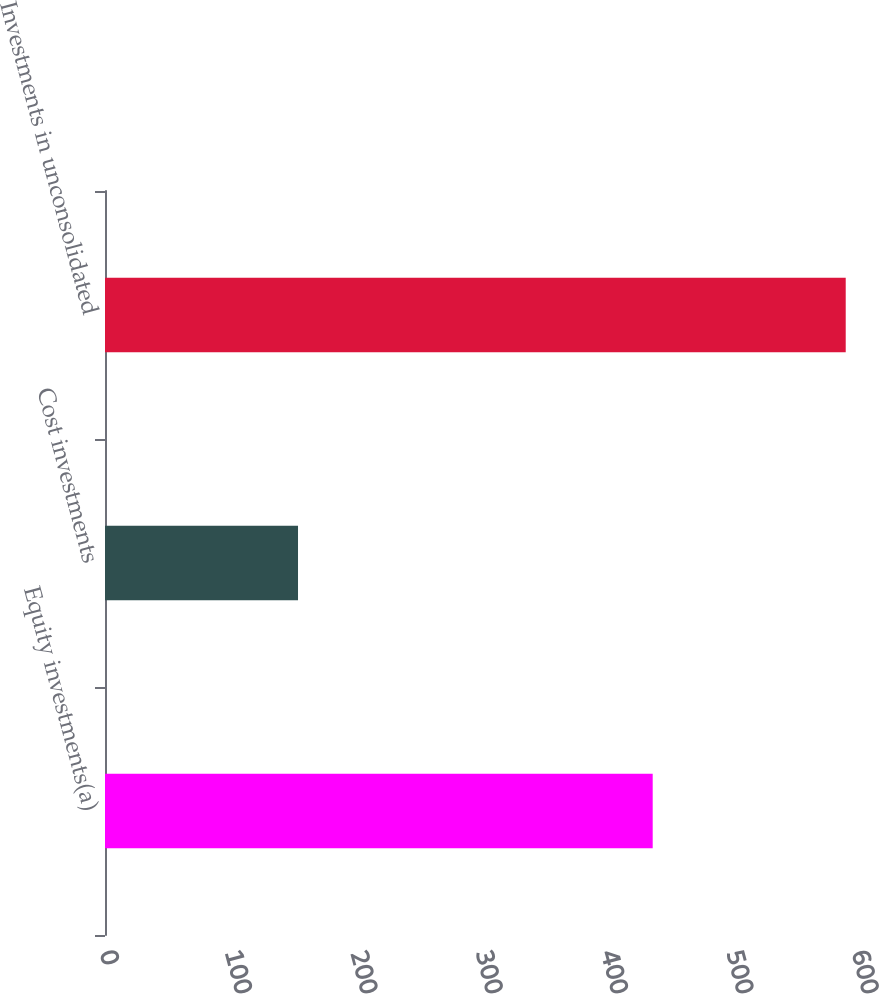Convert chart. <chart><loc_0><loc_0><loc_500><loc_500><bar_chart><fcel>Equity investments(a)<fcel>Cost investments<fcel>Investments in unconsolidated<nl><fcel>437<fcel>154<fcel>591<nl></chart> 